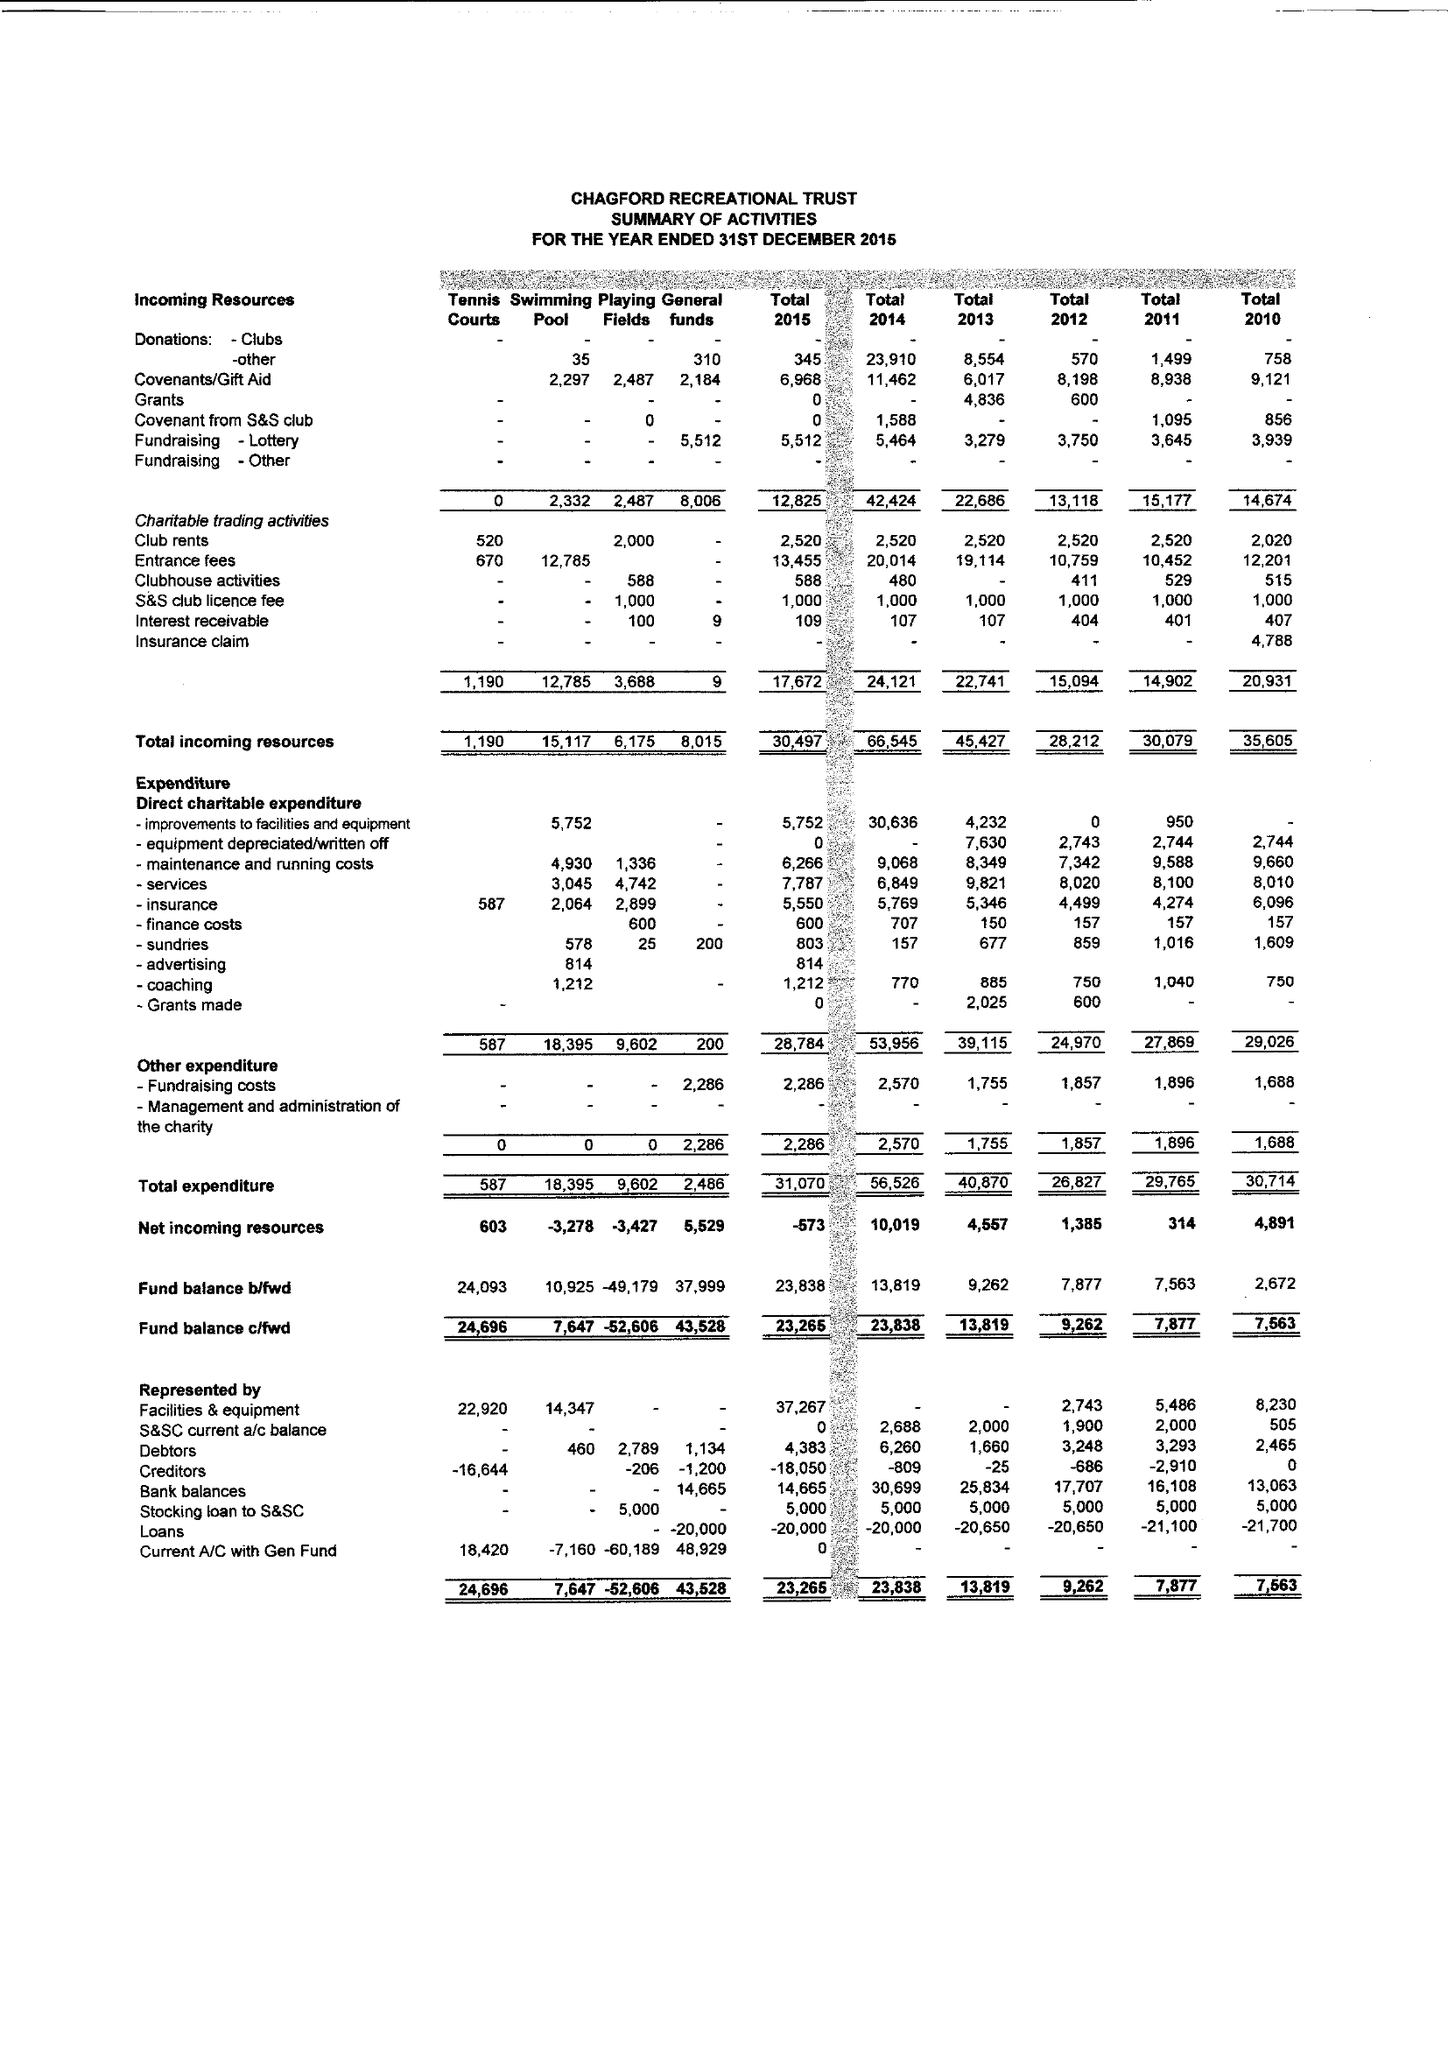What is the value for the address__postcode?
Answer the question using a single word or phrase. TQ13 8JW 